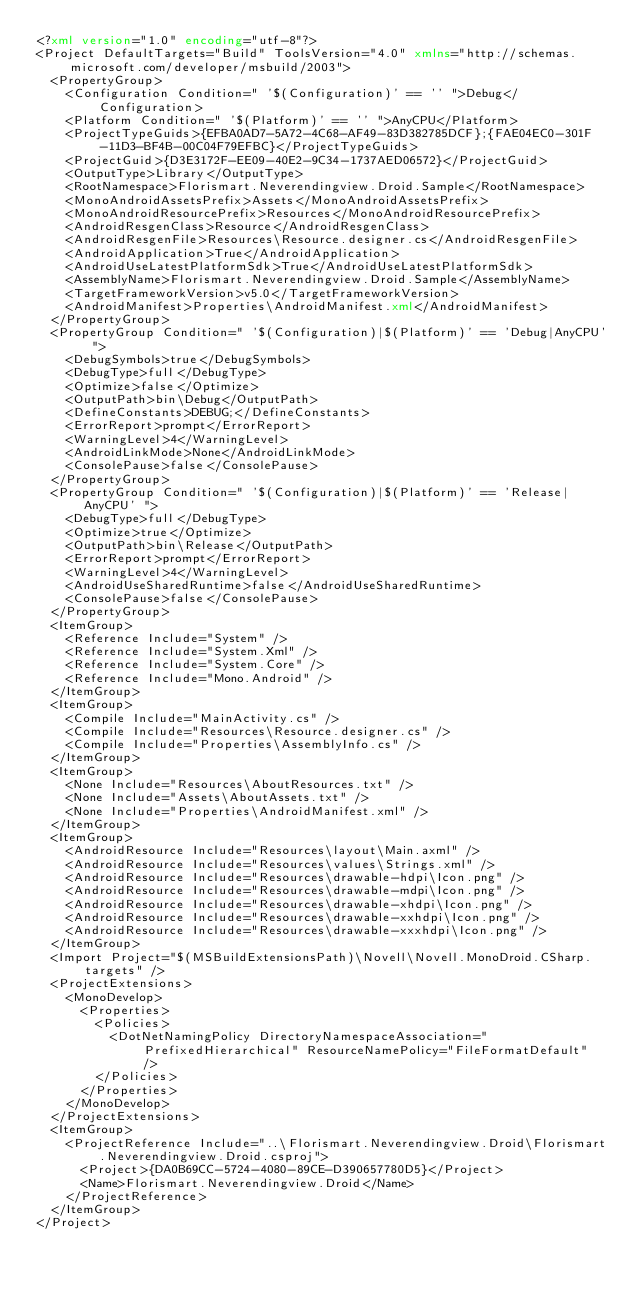Convert code to text. <code><loc_0><loc_0><loc_500><loc_500><_XML_><?xml version="1.0" encoding="utf-8"?>
<Project DefaultTargets="Build" ToolsVersion="4.0" xmlns="http://schemas.microsoft.com/developer/msbuild/2003">
  <PropertyGroup>
    <Configuration Condition=" '$(Configuration)' == '' ">Debug</Configuration>
    <Platform Condition=" '$(Platform)' == '' ">AnyCPU</Platform>
    <ProjectTypeGuids>{EFBA0AD7-5A72-4C68-AF49-83D382785DCF};{FAE04EC0-301F-11D3-BF4B-00C04F79EFBC}</ProjectTypeGuids>
    <ProjectGuid>{D3E3172F-EE09-40E2-9C34-1737AED06572}</ProjectGuid>
    <OutputType>Library</OutputType>
    <RootNamespace>Florismart.Neverendingview.Droid.Sample</RootNamespace>
    <MonoAndroidAssetsPrefix>Assets</MonoAndroidAssetsPrefix>
    <MonoAndroidResourcePrefix>Resources</MonoAndroidResourcePrefix>
    <AndroidResgenClass>Resource</AndroidResgenClass>
    <AndroidResgenFile>Resources\Resource.designer.cs</AndroidResgenFile>
    <AndroidApplication>True</AndroidApplication>
    <AndroidUseLatestPlatformSdk>True</AndroidUseLatestPlatformSdk>
    <AssemblyName>Florismart.Neverendingview.Droid.Sample</AssemblyName>
    <TargetFrameworkVersion>v5.0</TargetFrameworkVersion>
    <AndroidManifest>Properties\AndroidManifest.xml</AndroidManifest>
  </PropertyGroup>
  <PropertyGroup Condition=" '$(Configuration)|$(Platform)' == 'Debug|AnyCPU' ">
    <DebugSymbols>true</DebugSymbols>
    <DebugType>full</DebugType>
    <Optimize>false</Optimize>
    <OutputPath>bin\Debug</OutputPath>
    <DefineConstants>DEBUG;</DefineConstants>
    <ErrorReport>prompt</ErrorReport>
    <WarningLevel>4</WarningLevel>
    <AndroidLinkMode>None</AndroidLinkMode>
    <ConsolePause>false</ConsolePause>
  </PropertyGroup>
  <PropertyGroup Condition=" '$(Configuration)|$(Platform)' == 'Release|AnyCPU' ">
    <DebugType>full</DebugType>
    <Optimize>true</Optimize>
    <OutputPath>bin\Release</OutputPath>
    <ErrorReport>prompt</ErrorReport>
    <WarningLevel>4</WarningLevel>
    <AndroidUseSharedRuntime>false</AndroidUseSharedRuntime>
    <ConsolePause>false</ConsolePause>
  </PropertyGroup>
  <ItemGroup>
    <Reference Include="System" />
    <Reference Include="System.Xml" />
    <Reference Include="System.Core" />
    <Reference Include="Mono.Android" />
  </ItemGroup>
  <ItemGroup>
    <Compile Include="MainActivity.cs" />
    <Compile Include="Resources\Resource.designer.cs" />
    <Compile Include="Properties\AssemblyInfo.cs" />
  </ItemGroup>
  <ItemGroup>
    <None Include="Resources\AboutResources.txt" />
    <None Include="Assets\AboutAssets.txt" />
    <None Include="Properties\AndroidManifest.xml" />
  </ItemGroup>
  <ItemGroup>
    <AndroidResource Include="Resources\layout\Main.axml" />
    <AndroidResource Include="Resources\values\Strings.xml" />
    <AndroidResource Include="Resources\drawable-hdpi\Icon.png" />
    <AndroidResource Include="Resources\drawable-mdpi\Icon.png" />
    <AndroidResource Include="Resources\drawable-xhdpi\Icon.png" />
    <AndroidResource Include="Resources\drawable-xxhdpi\Icon.png" />
    <AndroidResource Include="Resources\drawable-xxxhdpi\Icon.png" />
  </ItemGroup>
  <Import Project="$(MSBuildExtensionsPath)\Novell\Novell.MonoDroid.CSharp.targets" />
  <ProjectExtensions>
    <MonoDevelop>
      <Properties>
        <Policies>
          <DotNetNamingPolicy DirectoryNamespaceAssociation="PrefixedHierarchical" ResourceNamePolicy="FileFormatDefault" />
        </Policies>
      </Properties>
    </MonoDevelop>
  </ProjectExtensions>
  <ItemGroup>
    <ProjectReference Include="..\Florismart.Neverendingview.Droid\Florismart.Neverendingview.Droid.csproj">
      <Project>{DA0B69CC-5724-4080-89CE-D390657780D5}</Project>
      <Name>Florismart.Neverendingview.Droid</Name>
    </ProjectReference>
  </ItemGroup>
</Project></code> 